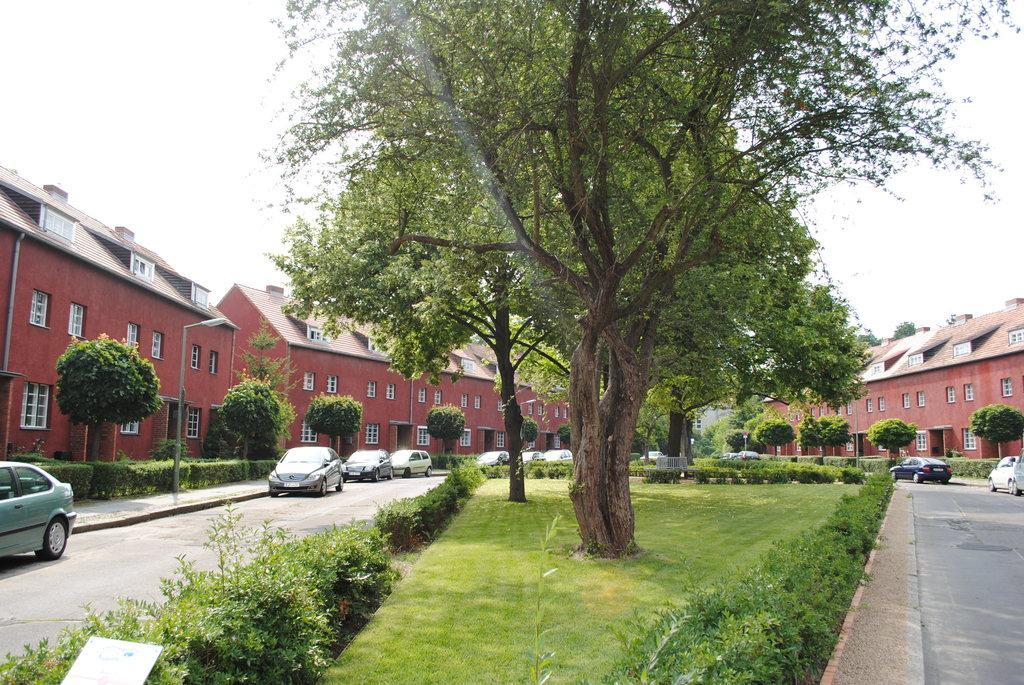How would you summarize this image in a sentence or two? This picture shows few buildings and we see cars parked and we see trees, plants and grass on the ground and we see a pole light on the sidewalk and we see a cloudy sky. 